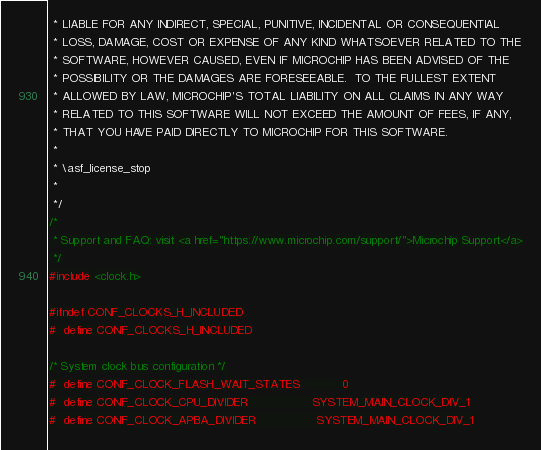<code> <loc_0><loc_0><loc_500><loc_500><_C_> * LIABLE FOR ANY INDIRECT, SPECIAL, PUNITIVE, INCIDENTAL OR CONSEQUENTIAL
 * LOSS, DAMAGE, COST OR EXPENSE OF ANY KIND WHATSOEVER RELATED TO THE
 * SOFTWARE, HOWEVER CAUSED, EVEN IF MICROCHIP HAS BEEN ADVISED OF THE
 * POSSIBILITY OR THE DAMAGES ARE FORESEEABLE.  TO THE FULLEST EXTENT
 * ALLOWED BY LAW, MICROCHIP'S TOTAL LIABILITY ON ALL CLAIMS IN ANY WAY
 * RELATED TO THIS SOFTWARE WILL NOT EXCEED THE AMOUNT OF FEES, IF ANY,
 * THAT YOU HAVE PAID DIRECTLY TO MICROCHIP FOR THIS SOFTWARE.
 *
 * \asf_license_stop
 *
 */
/*
 * Support and FAQ: visit <a href="https://www.microchip.com/support/">Microchip Support</a>
 */
#include <clock.h>

#ifndef CONF_CLOCKS_H_INCLUDED
#  define CONF_CLOCKS_H_INCLUDED

/* System clock bus configuration */
#  define CONF_CLOCK_FLASH_WAIT_STATES            0
#  define CONF_CLOCK_CPU_DIVIDER                  SYSTEM_MAIN_CLOCK_DIV_1
#  define CONF_CLOCK_APBA_DIVIDER                 SYSTEM_MAIN_CLOCK_DIV_1</code> 